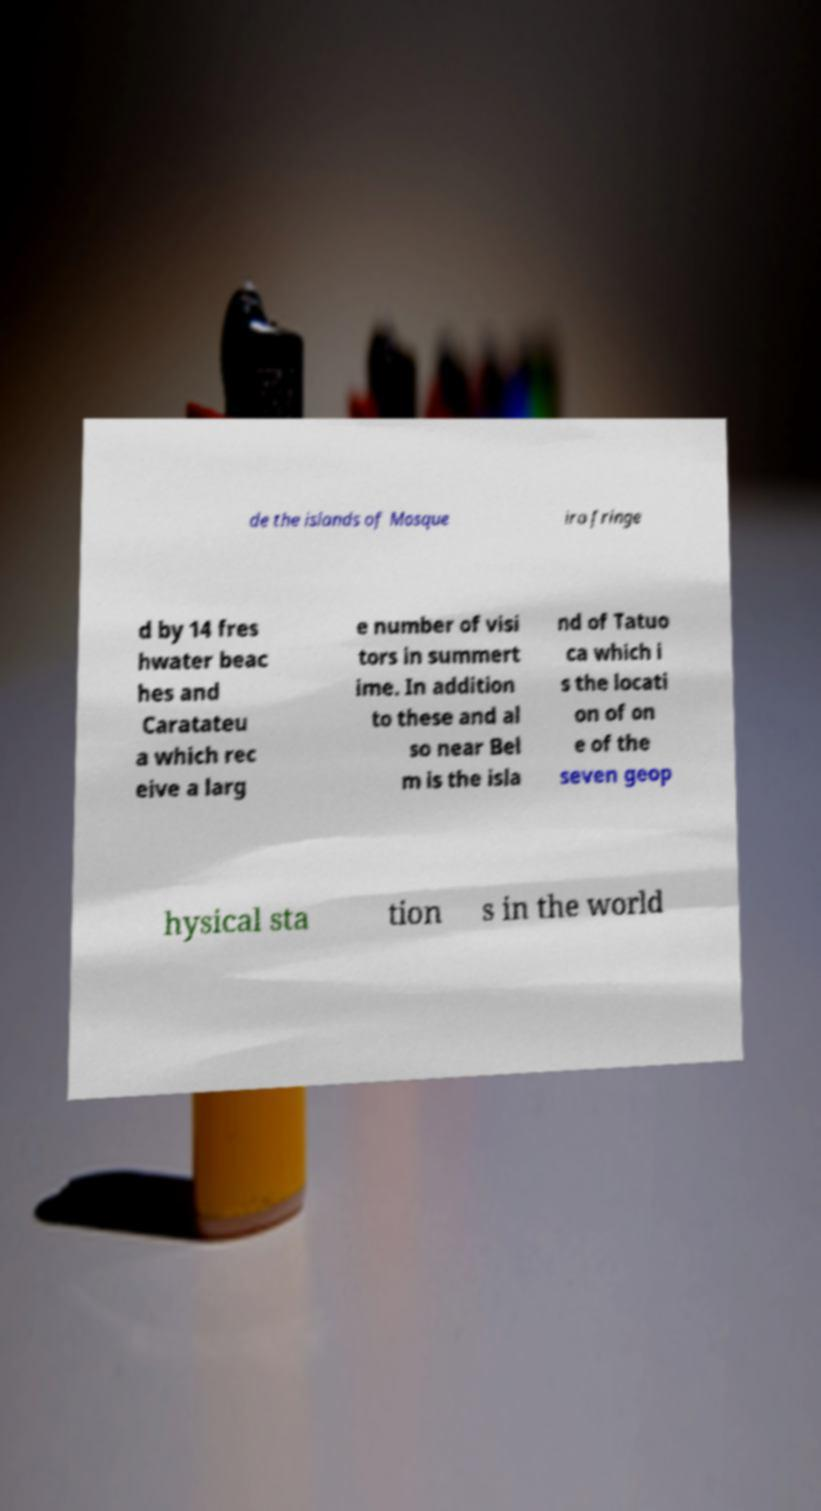Please identify and transcribe the text found in this image. de the islands of Mosque iro fringe d by 14 fres hwater beac hes and Caratateu a which rec eive a larg e number of visi tors in summert ime. In addition to these and al so near Bel m is the isla nd of Tatuo ca which i s the locati on of on e of the seven geop hysical sta tion s in the world 